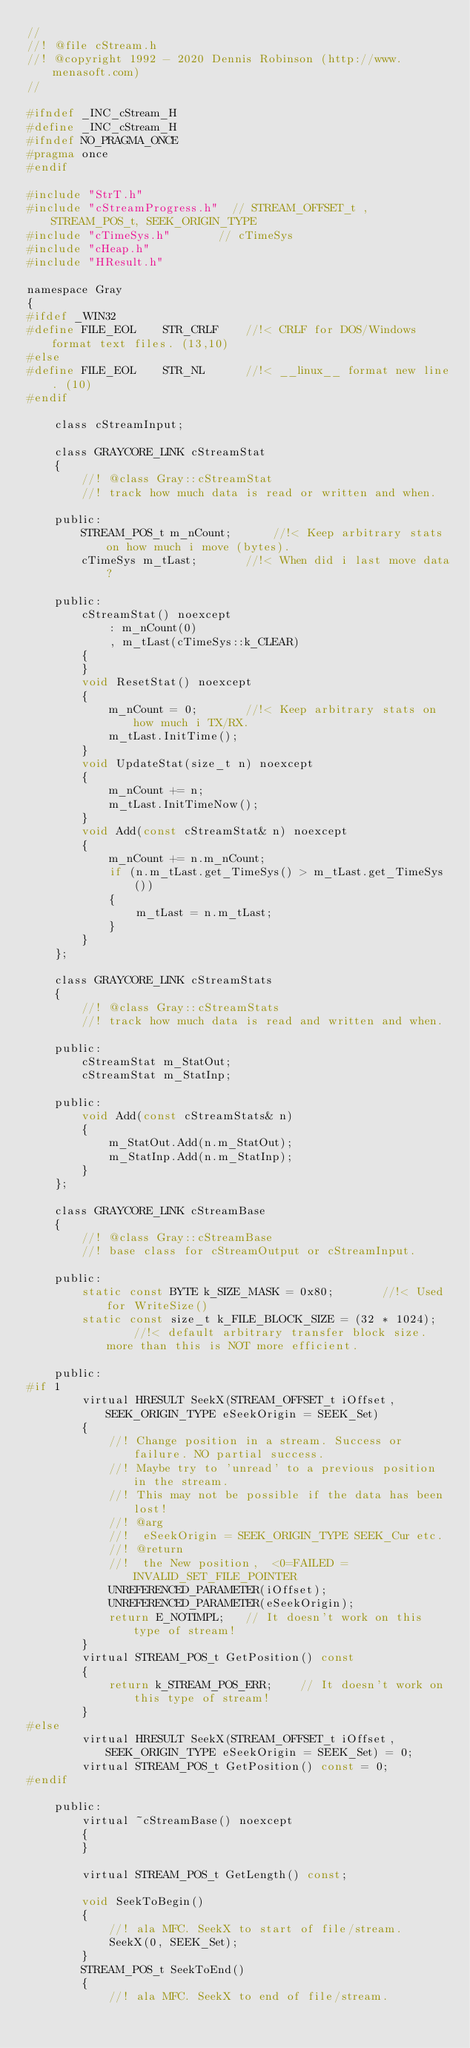<code> <loc_0><loc_0><loc_500><loc_500><_C_>//
//! @file cStream.h
//! @copyright 1992 - 2020 Dennis Robinson (http://www.menasoft.com)
//

#ifndef _INC_cStream_H
#define _INC_cStream_H
#ifndef NO_PRAGMA_ONCE
#pragma once
#endif

#include "StrT.h"
#include "cStreamProgress.h"  // STREAM_OFFSET_t , STREAM_POS_t, SEEK_ORIGIN_TYPE
#include "cTimeSys.h"		// cTimeSys
#include "cHeap.h"
#include "HResult.h"

namespace Gray
{
#ifdef _WIN32
#define FILE_EOL	STR_CRLF	//!< CRLF for DOS/Windows format text files. (13,10)
#else
#define FILE_EOL	STR_NL		//!< __linux__ format new line. (10)
#endif

	class cStreamInput;

	class GRAYCORE_LINK cStreamStat
	{
		//! @class Gray::cStreamStat
		//! track how much data is read or written and when.

	public:
		STREAM_POS_t m_nCount;		//!< Keep arbitrary stats on how much i move (bytes).
		cTimeSys m_tLast;		//!< When did i last move data?

	public:
		cStreamStat() noexcept
			: m_nCount(0)
			, m_tLast(cTimeSys::k_CLEAR)
		{
		}
		void ResetStat() noexcept
		{
			m_nCount = 0;		//!< Keep arbitrary stats on how much i TX/RX.
			m_tLast.InitTime();
		}
		void UpdateStat(size_t n) noexcept
		{
			m_nCount += n;
			m_tLast.InitTimeNow();
		}
		void Add(const cStreamStat& n) noexcept
		{
			m_nCount += n.m_nCount;
			if (n.m_tLast.get_TimeSys() > m_tLast.get_TimeSys())
			{
				m_tLast = n.m_tLast;
			}
		}
	};

	class GRAYCORE_LINK cStreamStats
	{
		//! @class Gray::cStreamStats
		//! track how much data is read and written and when.

	public:
		cStreamStat m_StatOut;
		cStreamStat m_StatInp;

	public:
		void Add(const cStreamStats& n)
		{
			m_StatOut.Add(n.m_StatOut);
			m_StatInp.Add(n.m_StatInp);
		}
	};

	class GRAYCORE_LINK cStreamBase
	{
		//! @class Gray::cStreamBase
		//! base class for cStreamOutput or cStreamInput.

	public:
		static const BYTE k_SIZE_MASK = 0x80;		//!< Used for WriteSize()
		static const size_t k_FILE_BLOCK_SIZE = (32 * 1024);	//!< default arbitrary transfer block size. more than this is NOT more efficient.

	public:
#if 1
		virtual HRESULT SeekX(STREAM_OFFSET_t iOffset, SEEK_ORIGIN_TYPE eSeekOrigin = SEEK_Set)
		{
			//! Change position in a stream. Success or failure. NO partial success.
			//! Maybe try to 'unread' to a previous position in the stream.
			//! This may not be possible if the data has been lost!
			//! @arg
			//!  eSeekOrigin = SEEK_ORIGIN_TYPE SEEK_Cur etc.
			//! @return
			//!  the New position,  <0=FAILED = INVALID_SET_FILE_POINTER
			UNREFERENCED_PARAMETER(iOffset);
			UNREFERENCED_PARAMETER(eSeekOrigin);
			return E_NOTIMPL;	// It doesn't work on this type of stream!
		}
		virtual STREAM_POS_t GetPosition() const
		{
			return k_STREAM_POS_ERR;	// It doesn't work on this type of stream!
		}
#else
		virtual HRESULT SeekX(STREAM_OFFSET_t iOffset, SEEK_ORIGIN_TYPE eSeekOrigin = SEEK_Set) = 0;
		virtual STREAM_POS_t GetPosition() const = 0;
#endif

	public:
		virtual ~cStreamBase() noexcept
		{
		}

		virtual STREAM_POS_t GetLength() const;

		void SeekToBegin()
		{
			//! ala MFC. SeekX to start of file/stream.
			SeekX(0, SEEK_Set);
		}
		STREAM_POS_t SeekToEnd()
		{
			//! ala MFC. SeekX to end of file/stream.</code> 